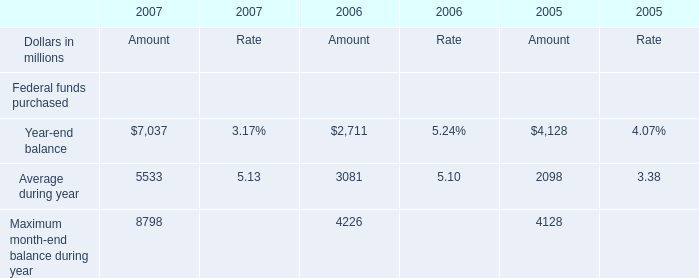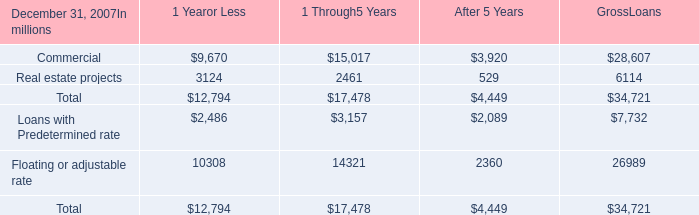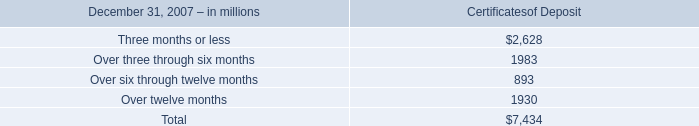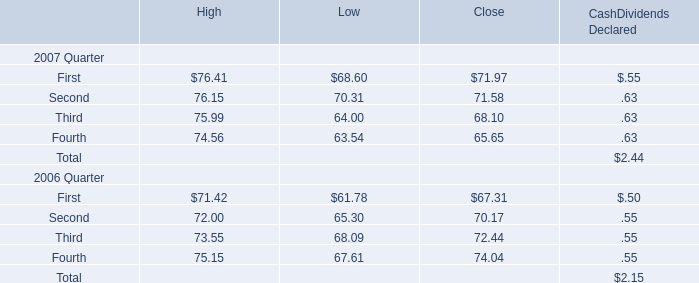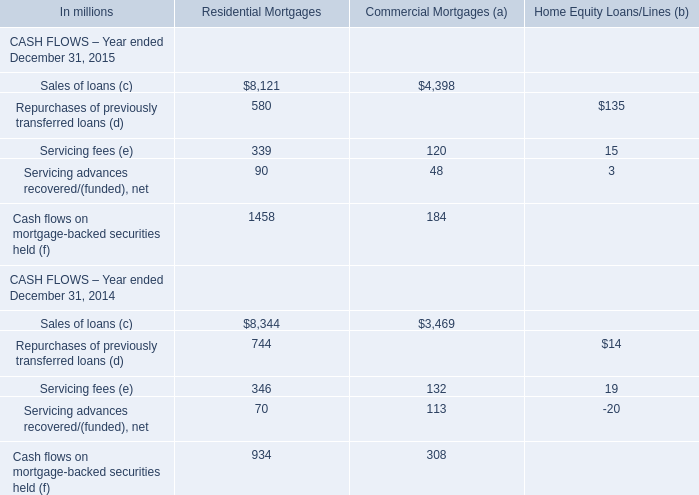What is the percentage of First in relation to the total in 2007 for High? 
Computations: (76.41 / (((76.41 + 76.15) + 75.99) + 74.56))
Answer: 0.25209. 